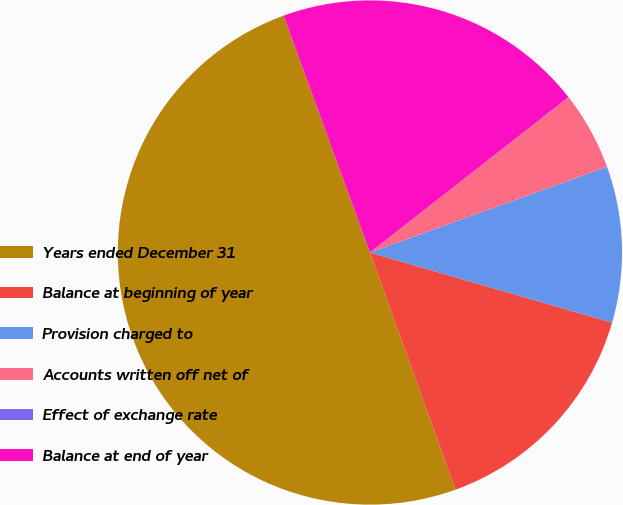Convert chart. <chart><loc_0><loc_0><loc_500><loc_500><pie_chart><fcel>Years ended December 31<fcel>Balance at beginning of year<fcel>Provision charged to<fcel>Accounts written off net of<fcel>Effect of exchange rate<fcel>Balance at end of year<nl><fcel>49.95%<fcel>15.0%<fcel>10.01%<fcel>5.02%<fcel>0.02%<fcel>20.0%<nl></chart> 